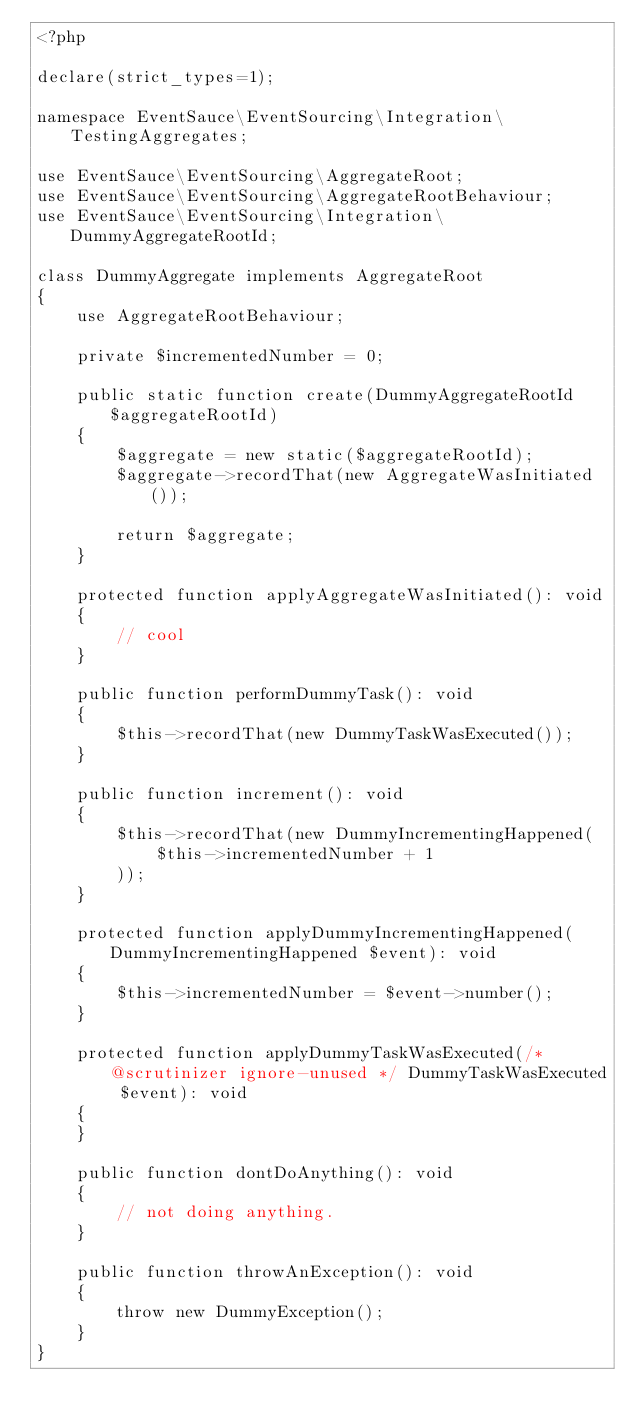<code> <loc_0><loc_0><loc_500><loc_500><_PHP_><?php

declare(strict_types=1);

namespace EventSauce\EventSourcing\Integration\TestingAggregates;

use EventSauce\EventSourcing\AggregateRoot;
use EventSauce\EventSourcing\AggregateRootBehaviour;
use EventSauce\EventSourcing\Integration\DummyAggregateRootId;

class DummyAggregate implements AggregateRoot
{
    use AggregateRootBehaviour;

    private $incrementedNumber = 0;

    public static function create(DummyAggregateRootId $aggregateRootId)
    {
        $aggregate = new static($aggregateRootId);
        $aggregate->recordThat(new AggregateWasInitiated());

        return $aggregate;
    }

    protected function applyAggregateWasInitiated(): void
    {
        // cool
    }

    public function performDummyTask(): void
    {
        $this->recordThat(new DummyTaskWasExecuted());
    }

    public function increment(): void
    {
        $this->recordThat(new DummyIncrementingHappened(
            $this->incrementedNumber + 1
        ));
    }

    protected function applyDummyIncrementingHappened(DummyIncrementingHappened $event): void
    {
        $this->incrementedNumber = $event->number();
    }

    protected function applyDummyTaskWasExecuted(/* @scrutinizer ignore-unused */ DummyTaskWasExecuted $event): void
    {
    }

    public function dontDoAnything(): void
    {
        // not doing anything.
    }

    public function throwAnException(): void
    {
        throw new DummyException();
    }
}
</code> 